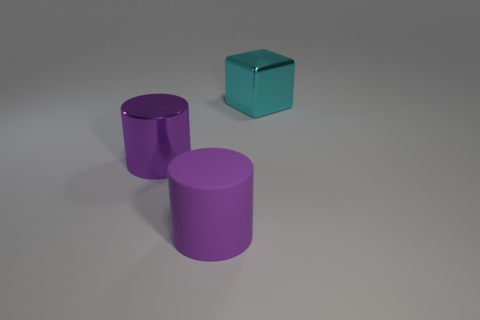Add 1 tiny cylinders. How many objects exist? 4 Subtract all cubes. How many objects are left? 2 Subtract 0 brown balls. How many objects are left? 3 Subtract all large shiny things. Subtract all purple metallic balls. How many objects are left? 1 Add 1 large shiny cylinders. How many large shiny cylinders are left? 2 Add 3 rubber objects. How many rubber objects exist? 4 